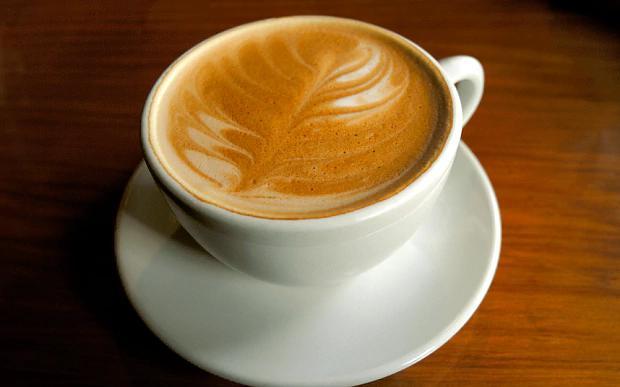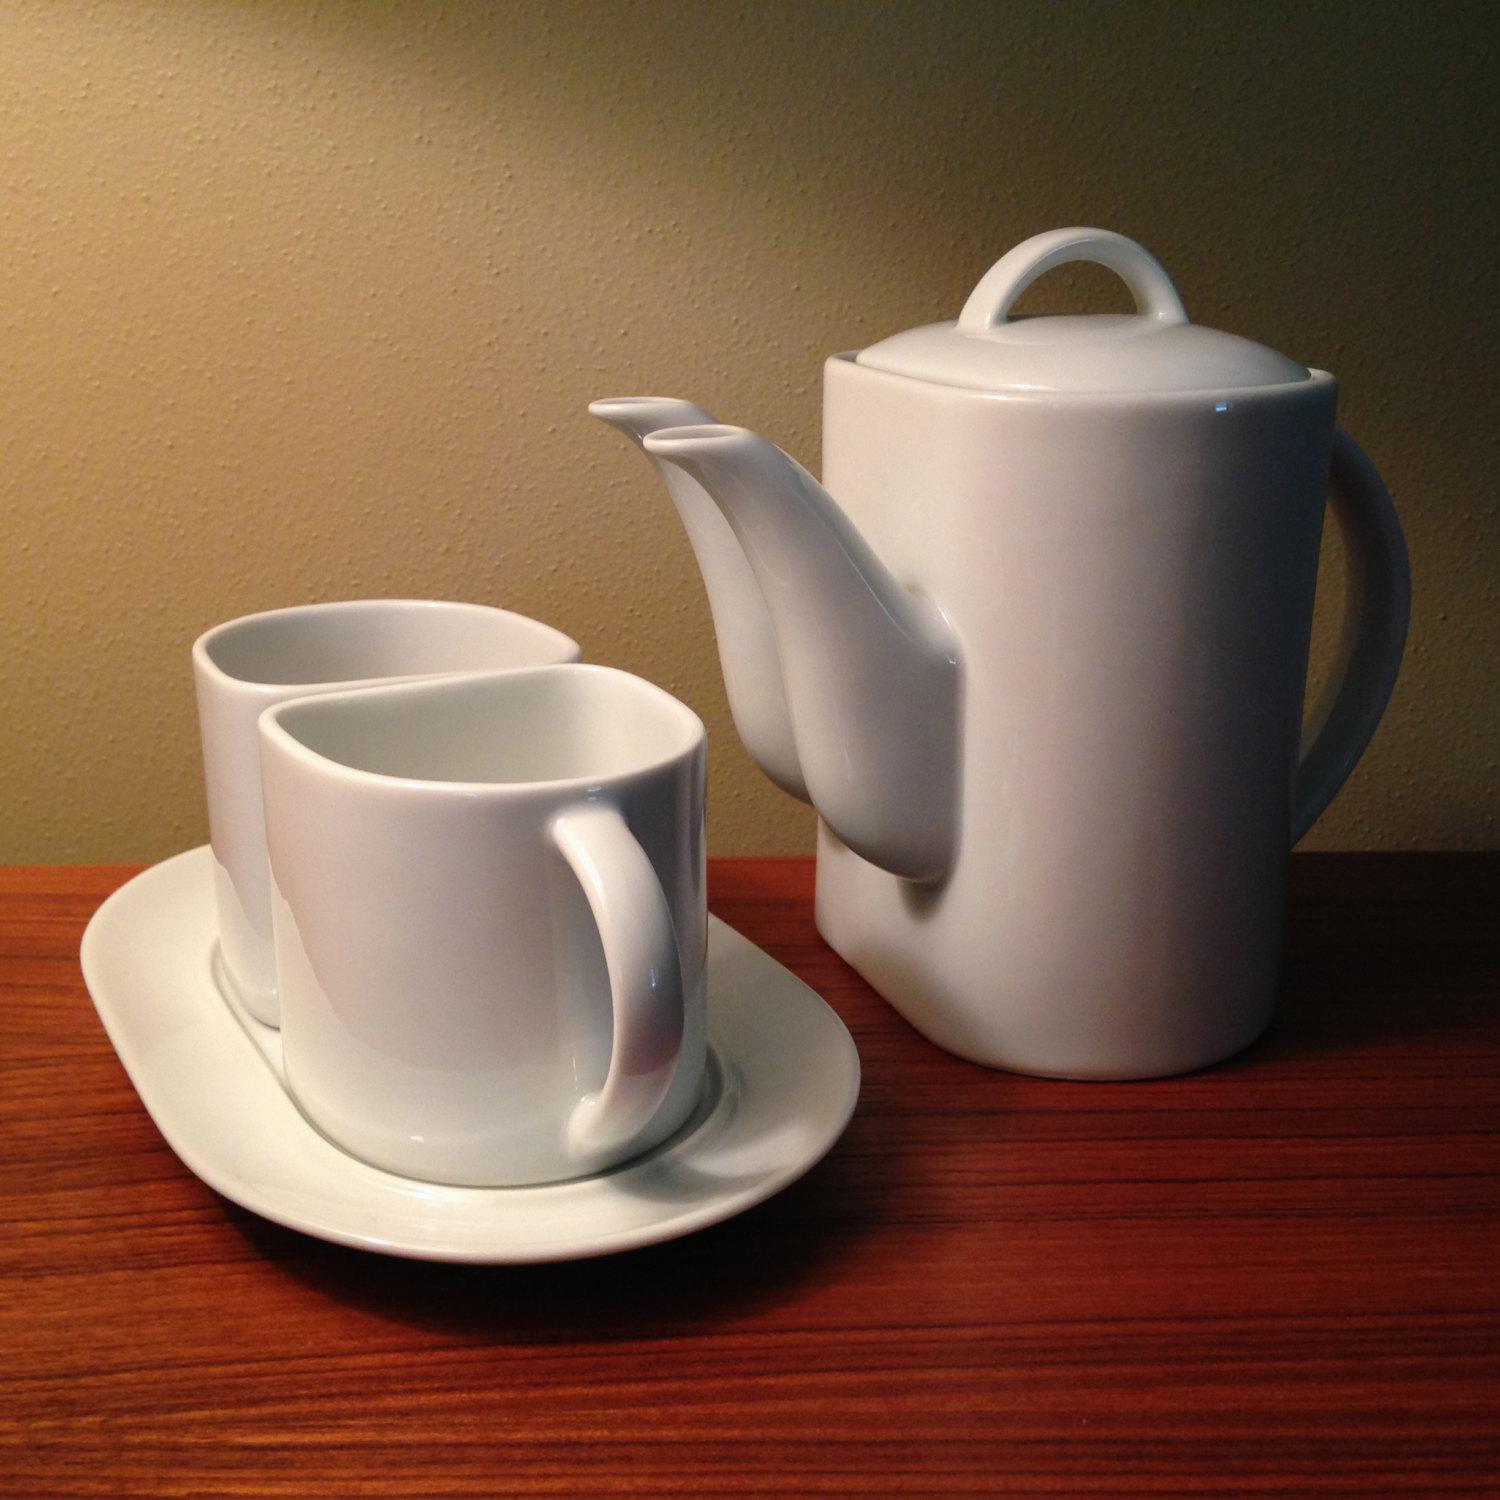The first image is the image on the left, the second image is the image on the right. For the images displayed, is the sentence "Two cups for hot drinks are in each image, each sitting on a matching saucer." factually correct? Answer yes or no. No. The first image is the image on the left, the second image is the image on the right. For the images shown, is this caption "One image appears to depict two completely empty cups." true? Answer yes or no. Yes. The first image is the image on the left, the second image is the image on the right. Analyze the images presented: Is the assertion "Left image shows two cups of the same beverages on white saucers." valid? Answer yes or no. No. The first image is the image on the left, the second image is the image on the right. For the images shown, is this caption "There are four tea cups sitting  on saucers." true? Answer yes or no. No. 